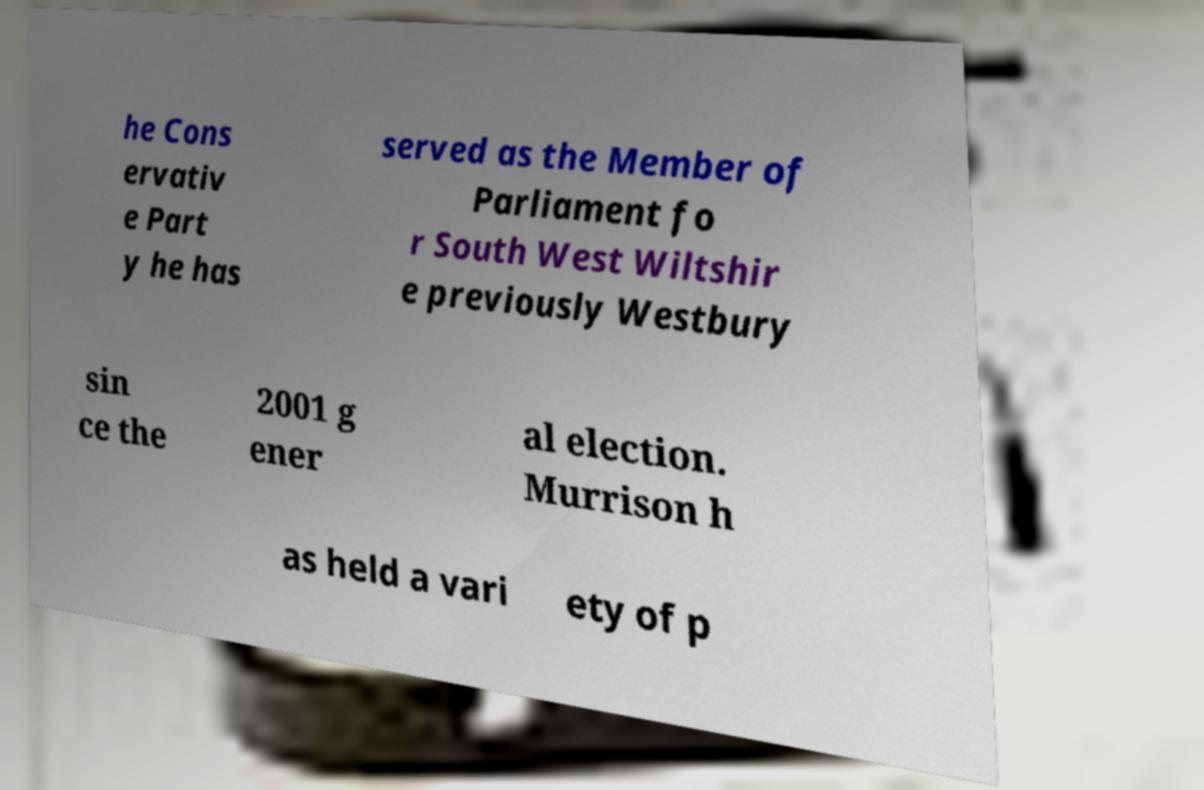Can you read and provide the text displayed in the image?This photo seems to have some interesting text. Can you extract and type it out for me? he Cons ervativ e Part y he has served as the Member of Parliament fo r South West Wiltshir e previously Westbury sin ce the 2001 g ener al election. Murrison h as held a vari ety of p 